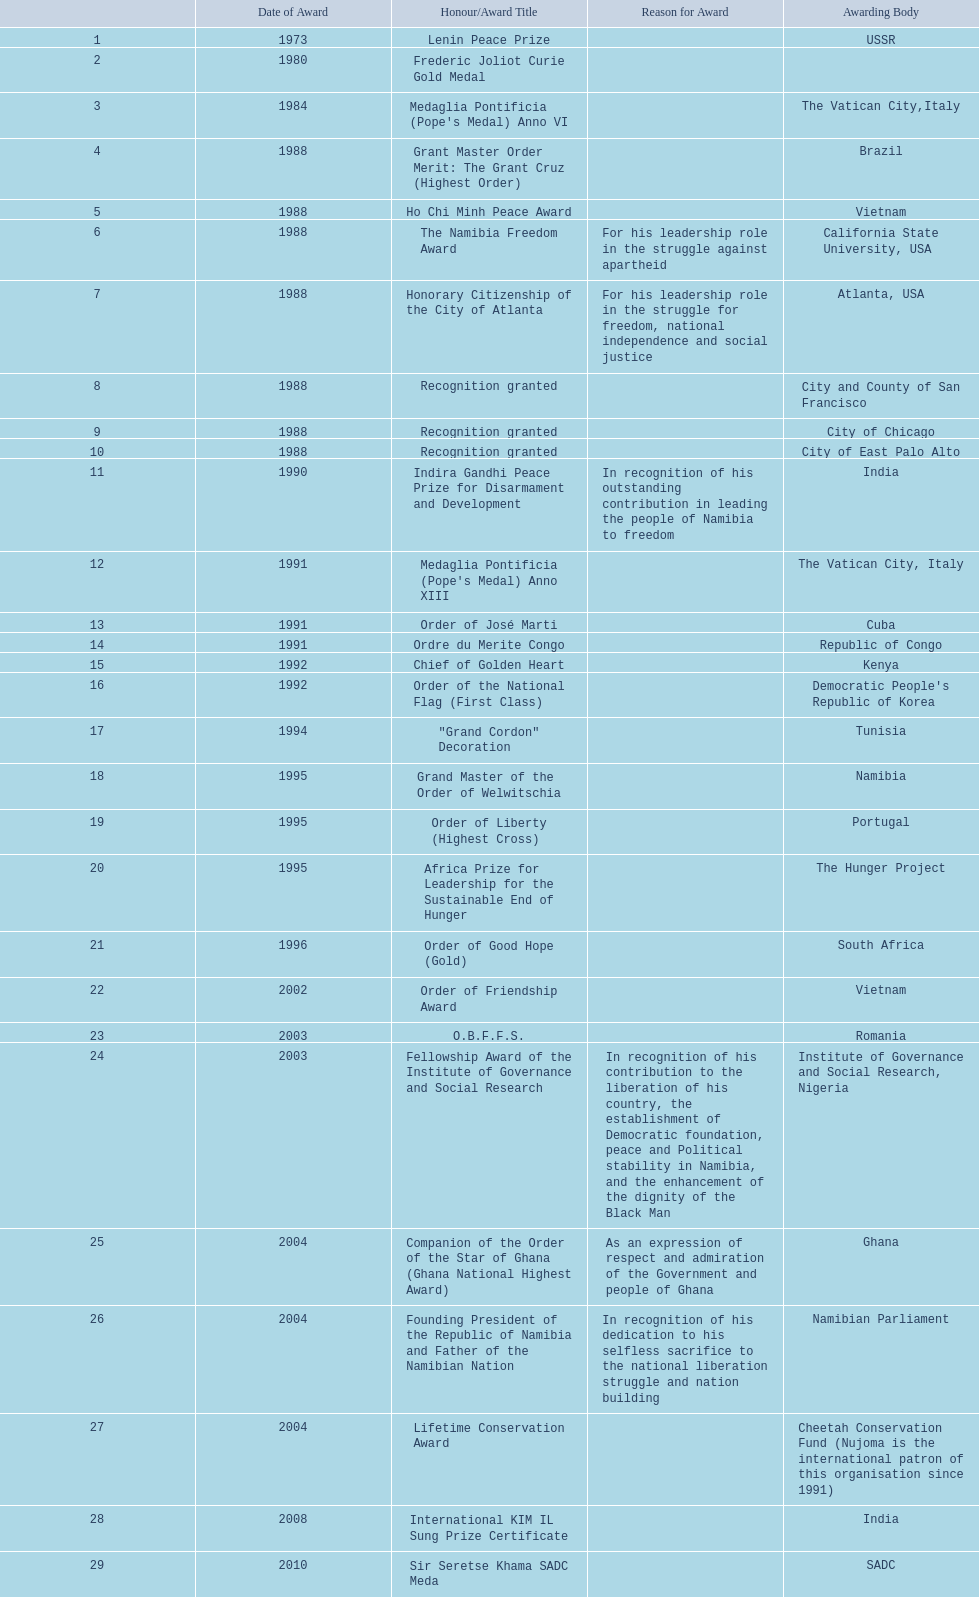What prizes has sam nujoma been bestowed? Lenin Peace Prize, Frederic Joliot Curie Gold Medal, Medaglia Pontificia (Pope's Medal) Anno VI, Grant Master Order Merit: The Grant Cruz (Highest Order), Ho Chi Minh Peace Award, The Namibia Freedom Award, Honorary Citizenship of the City of Atlanta, Recognition granted, Recognition granted, Recognition granted, Indira Gandhi Peace Prize for Disarmament and Development, Medaglia Pontificia (Pope's Medal) Anno XIII, Order of José Marti, Ordre du Merite Congo, Chief of Golden Heart, Order of the National Flag (First Class), "Grand Cordon" Decoration, Grand Master of the Order of Welwitschia, Order of Liberty (Highest Cross), Africa Prize for Leadership for the Sustainable End of Hunger, Order of Good Hope (Gold), Order of Friendship Award, O.B.F.F.S., Fellowship Award of the Institute of Governance and Social Research, Companion of the Order of the Star of Ghana (Ghana National Highest Award), Founding President of the Republic of Namibia and Father of the Namibian Nation, Lifetime Conservation Award, International KIM IL Sung Prize Certificate, Sir Seretse Khama SADC Meda. By which conferring entity did sam nujoma acquire the o.b.f.f.s. award? Romania. 